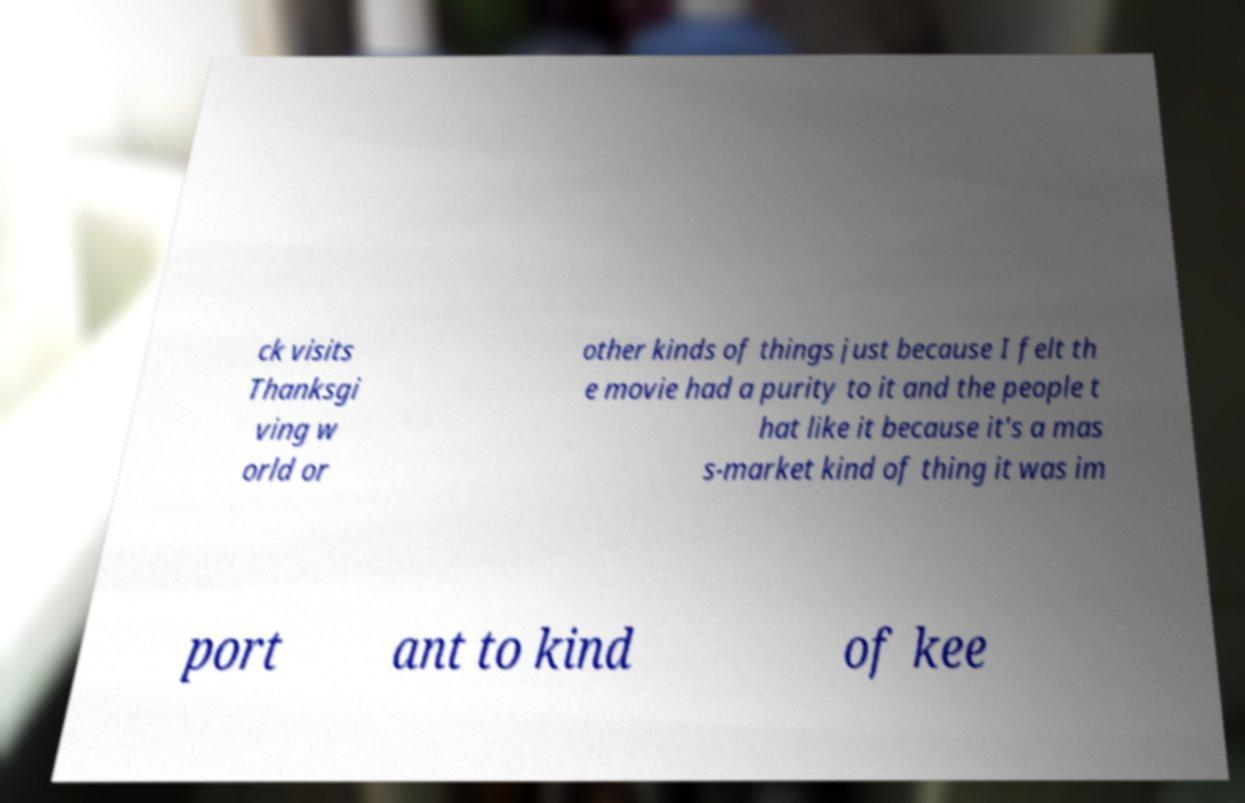I need the written content from this picture converted into text. Can you do that? ck visits Thanksgi ving w orld or other kinds of things just because I felt th e movie had a purity to it and the people t hat like it because it's a mas s-market kind of thing it was im port ant to kind of kee 